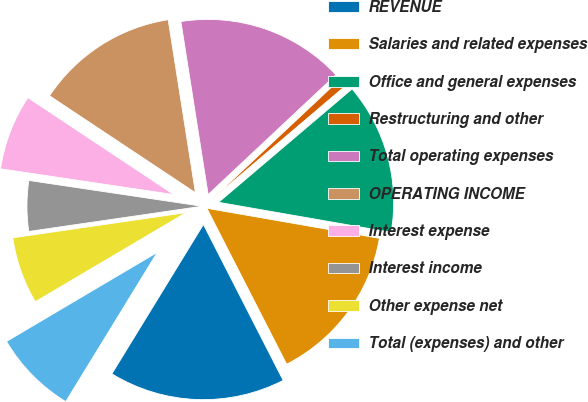Convert chart. <chart><loc_0><loc_0><loc_500><loc_500><pie_chart><fcel>REVENUE<fcel>Salaries and related expenses<fcel>Office and general expenses<fcel>Restructuring and other<fcel>Total operating expenses<fcel>OPERATING INCOME<fcel>Interest expense<fcel>Interest income<fcel>Other expense net<fcel>Total (expenses) and other<nl><fcel>16.28%<fcel>14.73%<fcel>13.95%<fcel>0.78%<fcel>15.5%<fcel>13.18%<fcel>6.98%<fcel>4.65%<fcel>6.2%<fcel>7.75%<nl></chart> 